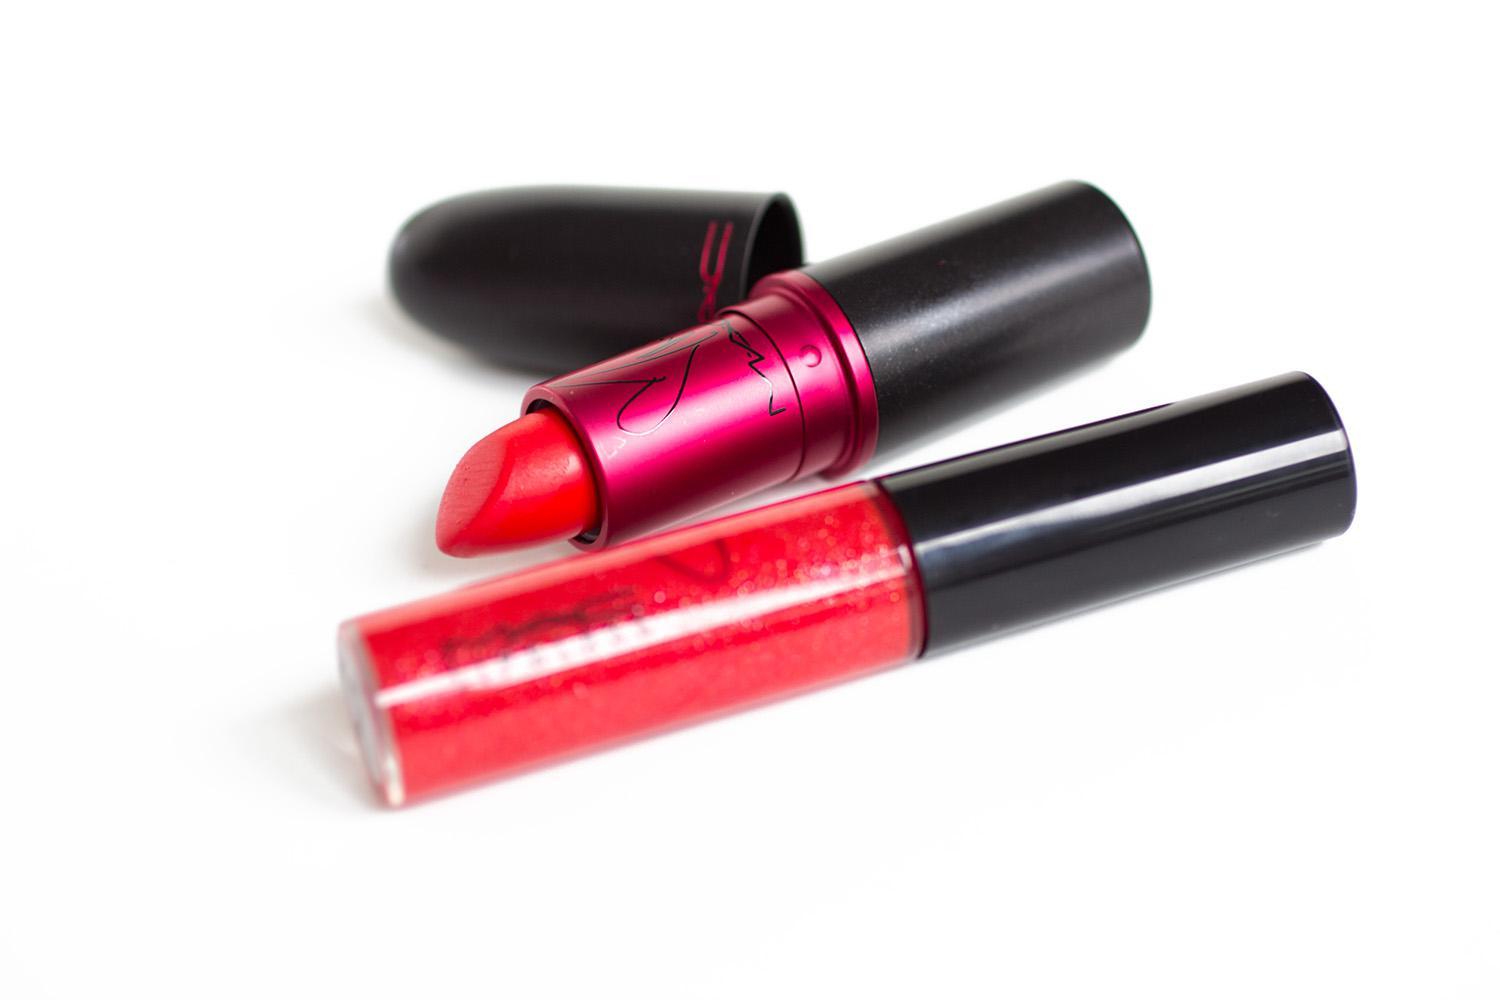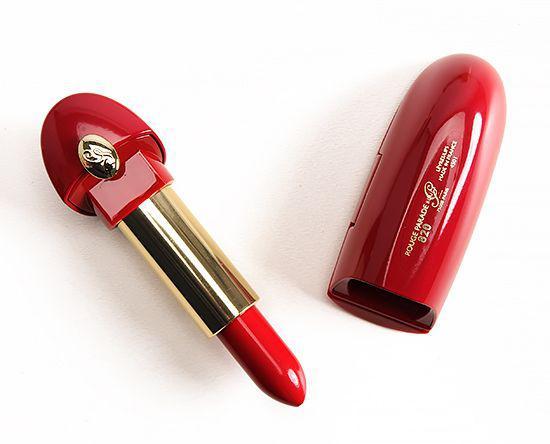The first image is the image on the left, the second image is the image on the right. Considering the images on both sides, is "There is at least one lipgloss." valid? Answer yes or no. Yes. The first image is the image on the left, the second image is the image on the right. Given the left and right images, does the statement "A light pink lipstick is featured in both images." hold true? Answer yes or no. No. 